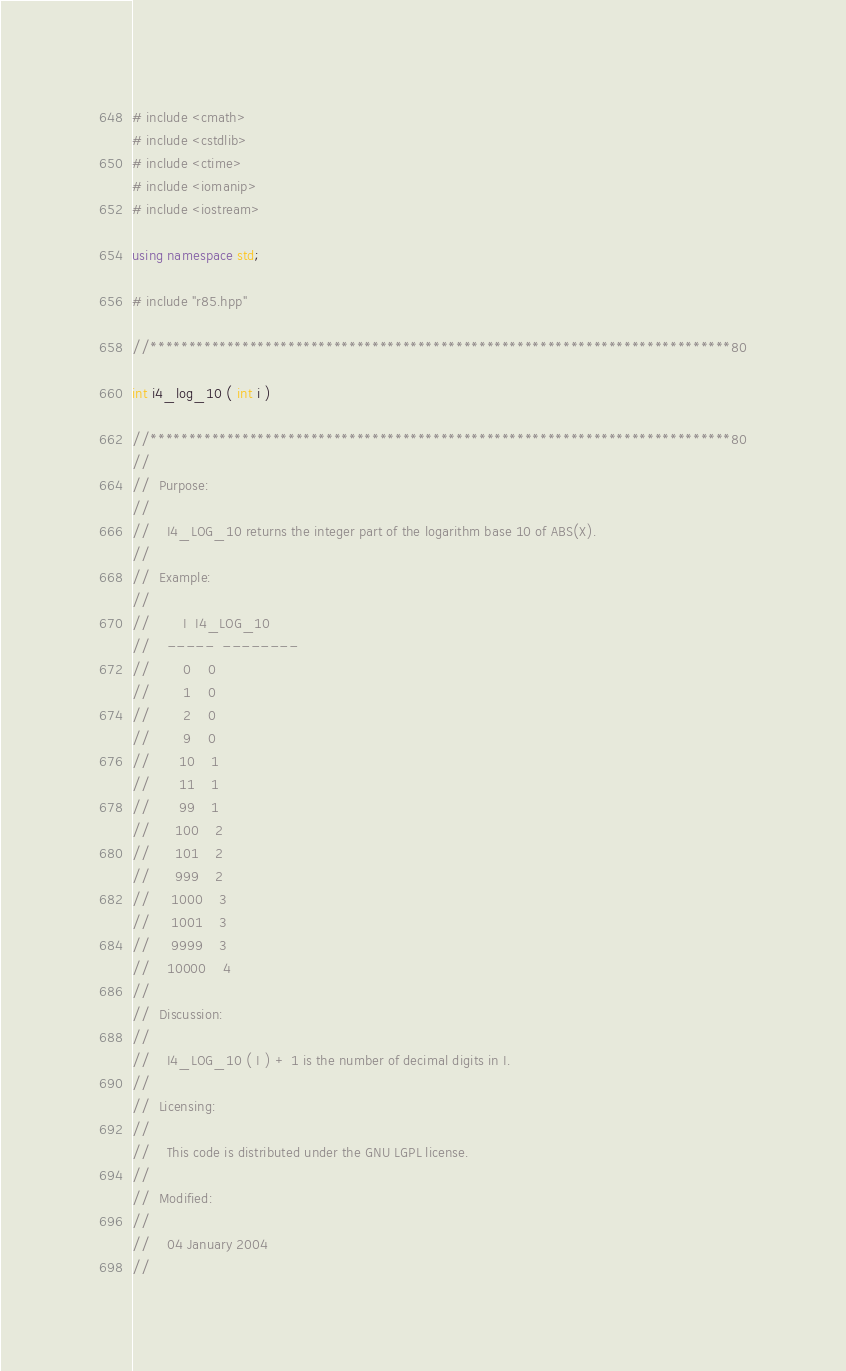Convert code to text. <code><loc_0><loc_0><loc_500><loc_500><_C++_># include <cmath>
# include <cstdlib>
# include <ctime>
# include <iomanip>
# include <iostream>

using namespace std;

# include "r85.hpp"

//****************************************************************************80

int i4_log_10 ( int i )

//****************************************************************************80
//
//  Purpose:
//
//    I4_LOG_10 returns the integer part of the logarithm base 10 of ABS(X).
//
//  Example:
//
//        I  I4_LOG_10
//    -----  --------
//        0    0
//        1    0
//        2    0
//        9    0
//       10    1
//       11    1
//       99    1
//      100    2
//      101    2
//      999    2
//     1000    3
//     1001    3
//     9999    3
//    10000    4
//
//  Discussion:
//
//    I4_LOG_10 ( I ) + 1 is the number of decimal digits in I.
//
//  Licensing:
//
//    This code is distributed under the GNU LGPL license. 
//
//  Modified:
//
//    04 January 2004
//</code> 